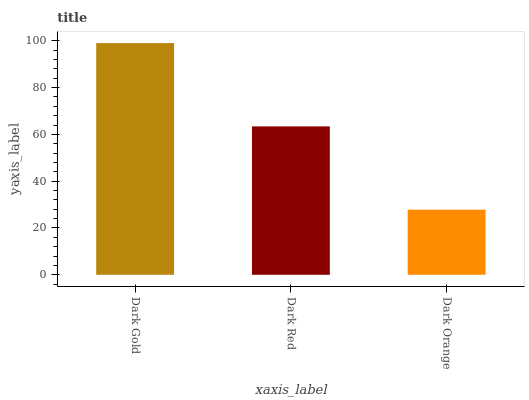Is Dark Red the minimum?
Answer yes or no. No. Is Dark Red the maximum?
Answer yes or no. No. Is Dark Gold greater than Dark Red?
Answer yes or no. Yes. Is Dark Red less than Dark Gold?
Answer yes or no. Yes. Is Dark Red greater than Dark Gold?
Answer yes or no. No. Is Dark Gold less than Dark Red?
Answer yes or no. No. Is Dark Red the high median?
Answer yes or no. Yes. Is Dark Red the low median?
Answer yes or no. Yes. Is Dark Orange the high median?
Answer yes or no. No. Is Dark Gold the low median?
Answer yes or no. No. 